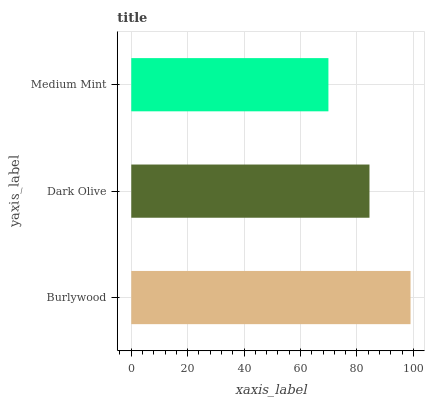Is Medium Mint the minimum?
Answer yes or no. Yes. Is Burlywood the maximum?
Answer yes or no. Yes. Is Dark Olive the minimum?
Answer yes or no. No. Is Dark Olive the maximum?
Answer yes or no. No. Is Burlywood greater than Dark Olive?
Answer yes or no. Yes. Is Dark Olive less than Burlywood?
Answer yes or no. Yes. Is Dark Olive greater than Burlywood?
Answer yes or no. No. Is Burlywood less than Dark Olive?
Answer yes or no. No. Is Dark Olive the high median?
Answer yes or no. Yes. Is Dark Olive the low median?
Answer yes or no. Yes. Is Burlywood the high median?
Answer yes or no. No. Is Burlywood the low median?
Answer yes or no. No. 